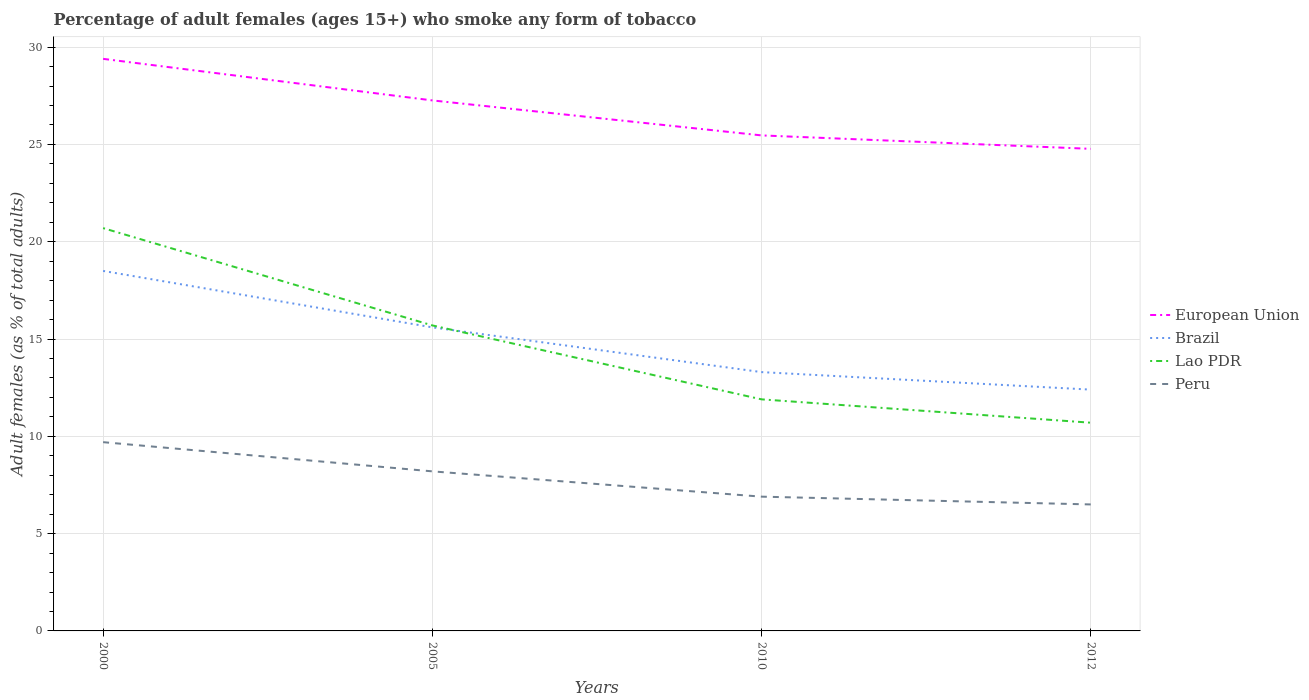Is the number of lines equal to the number of legend labels?
Give a very brief answer. Yes. Across all years, what is the maximum percentage of adult females who smoke in Peru?
Make the answer very short. 6.5. In which year was the percentage of adult females who smoke in European Union maximum?
Keep it short and to the point. 2012. What is the total percentage of adult females who smoke in Peru in the graph?
Offer a terse response. 3.2. What is the difference between the highest and the second highest percentage of adult females who smoke in European Union?
Give a very brief answer. 4.62. What is the difference between the highest and the lowest percentage of adult females who smoke in Lao PDR?
Keep it short and to the point. 2. How many lines are there?
Your answer should be very brief. 4. Are the values on the major ticks of Y-axis written in scientific E-notation?
Offer a very short reply. No. Does the graph contain any zero values?
Your answer should be very brief. No. Does the graph contain grids?
Make the answer very short. Yes. How many legend labels are there?
Make the answer very short. 4. How are the legend labels stacked?
Make the answer very short. Vertical. What is the title of the graph?
Offer a terse response. Percentage of adult females (ages 15+) who smoke any form of tobacco. What is the label or title of the Y-axis?
Offer a terse response. Adult females (as % of total adults). What is the Adult females (as % of total adults) of European Union in 2000?
Offer a very short reply. 29.4. What is the Adult females (as % of total adults) of Brazil in 2000?
Your answer should be very brief. 18.5. What is the Adult females (as % of total adults) of Lao PDR in 2000?
Give a very brief answer. 20.7. What is the Adult females (as % of total adults) in European Union in 2005?
Your response must be concise. 27.26. What is the Adult females (as % of total adults) of Brazil in 2005?
Your answer should be very brief. 15.6. What is the Adult females (as % of total adults) in Lao PDR in 2005?
Provide a short and direct response. 15.7. What is the Adult females (as % of total adults) in Peru in 2005?
Your answer should be very brief. 8.2. What is the Adult females (as % of total adults) in European Union in 2010?
Your response must be concise. 25.46. What is the Adult females (as % of total adults) in Brazil in 2010?
Provide a succinct answer. 13.3. What is the Adult females (as % of total adults) of Lao PDR in 2010?
Your answer should be very brief. 11.9. What is the Adult females (as % of total adults) in European Union in 2012?
Give a very brief answer. 24.77. What is the Adult females (as % of total adults) of Brazil in 2012?
Keep it short and to the point. 12.4. What is the Adult females (as % of total adults) in Lao PDR in 2012?
Your answer should be compact. 10.7. What is the Adult females (as % of total adults) of Peru in 2012?
Offer a terse response. 6.5. Across all years, what is the maximum Adult females (as % of total adults) of European Union?
Offer a terse response. 29.4. Across all years, what is the maximum Adult females (as % of total adults) in Lao PDR?
Give a very brief answer. 20.7. Across all years, what is the minimum Adult females (as % of total adults) of European Union?
Give a very brief answer. 24.77. Across all years, what is the minimum Adult females (as % of total adults) in Lao PDR?
Ensure brevity in your answer.  10.7. Across all years, what is the minimum Adult females (as % of total adults) of Peru?
Give a very brief answer. 6.5. What is the total Adult females (as % of total adults) of European Union in the graph?
Your answer should be very brief. 106.9. What is the total Adult females (as % of total adults) in Brazil in the graph?
Give a very brief answer. 59.8. What is the total Adult females (as % of total adults) in Peru in the graph?
Offer a very short reply. 31.3. What is the difference between the Adult females (as % of total adults) in European Union in 2000 and that in 2005?
Offer a terse response. 2.14. What is the difference between the Adult females (as % of total adults) in Lao PDR in 2000 and that in 2005?
Provide a short and direct response. 5. What is the difference between the Adult females (as % of total adults) of Peru in 2000 and that in 2005?
Keep it short and to the point. 1.5. What is the difference between the Adult females (as % of total adults) in European Union in 2000 and that in 2010?
Provide a short and direct response. 3.93. What is the difference between the Adult females (as % of total adults) of Brazil in 2000 and that in 2010?
Your answer should be compact. 5.2. What is the difference between the Adult females (as % of total adults) of Lao PDR in 2000 and that in 2010?
Provide a short and direct response. 8.8. What is the difference between the Adult females (as % of total adults) of Peru in 2000 and that in 2010?
Provide a short and direct response. 2.8. What is the difference between the Adult females (as % of total adults) in European Union in 2000 and that in 2012?
Provide a short and direct response. 4.62. What is the difference between the Adult females (as % of total adults) of Brazil in 2000 and that in 2012?
Give a very brief answer. 6.1. What is the difference between the Adult females (as % of total adults) of Lao PDR in 2000 and that in 2012?
Offer a terse response. 10. What is the difference between the Adult females (as % of total adults) in Peru in 2000 and that in 2012?
Provide a succinct answer. 3.2. What is the difference between the Adult females (as % of total adults) in European Union in 2005 and that in 2010?
Make the answer very short. 1.8. What is the difference between the Adult females (as % of total adults) in Lao PDR in 2005 and that in 2010?
Offer a very short reply. 3.8. What is the difference between the Adult females (as % of total adults) in European Union in 2005 and that in 2012?
Offer a terse response. 2.49. What is the difference between the Adult females (as % of total adults) of Lao PDR in 2005 and that in 2012?
Give a very brief answer. 5. What is the difference between the Adult females (as % of total adults) in European Union in 2010 and that in 2012?
Your answer should be very brief. 0.69. What is the difference between the Adult females (as % of total adults) in Brazil in 2010 and that in 2012?
Keep it short and to the point. 0.9. What is the difference between the Adult females (as % of total adults) in Lao PDR in 2010 and that in 2012?
Your answer should be compact. 1.2. What is the difference between the Adult females (as % of total adults) of European Union in 2000 and the Adult females (as % of total adults) of Brazil in 2005?
Your answer should be compact. 13.8. What is the difference between the Adult females (as % of total adults) in European Union in 2000 and the Adult females (as % of total adults) in Lao PDR in 2005?
Offer a very short reply. 13.7. What is the difference between the Adult females (as % of total adults) of European Union in 2000 and the Adult females (as % of total adults) of Peru in 2005?
Your response must be concise. 21.2. What is the difference between the Adult females (as % of total adults) of European Union in 2000 and the Adult females (as % of total adults) of Brazil in 2010?
Give a very brief answer. 16.1. What is the difference between the Adult females (as % of total adults) in European Union in 2000 and the Adult females (as % of total adults) in Lao PDR in 2010?
Offer a very short reply. 17.5. What is the difference between the Adult females (as % of total adults) in European Union in 2000 and the Adult females (as % of total adults) in Peru in 2010?
Keep it short and to the point. 22.5. What is the difference between the Adult females (as % of total adults) in Brazil in 2000 and the Adult females (as % of total adults) in Lao PDR in 2010?
Provide a short and direct response. 6.6. What is the difference between the Adult females (as % of total adults) in European Union in 2000 and the Adult females (as % of total adults) in Brazil in 2012?
Offer a terse response. 17. What is the difference between the Adult females (as % of total adults) of European Union in 2000 and the Adult females (as % of total adults) of Lao PDR in 2012?
Your response must be concise. 18.7. What is the difference between the Adult females (as % of total adults) of European Union in 2000 and the Adult females (as % of total adults) of Peru in 2012?
Provide a succinct answer. 22.9. What is the difference between the Adult females (as % of total adults) in Brazil in 2000 and the Adult females (as % of total adults) in Lao PDR in 2012?
Offer a terse response. 7.8. What is the difference between the Adult females (as % of total adults) of European Union in 2005 and the Adult females (as % of total adults) of Brazil in 2010?
Your response must be concise. 13.96. What is the difference between the Adult females (as % of total adults) of European Union in 2005 and the Adult females (as % of total adults) of Lao PDR in 2010?
Ensure brevity in your answer.  15.36. What is the difference between the Adult females (as % of total adults) of European Union in 2005 and the Adult females (as % of total adults) of Peru in 2010?
Keep it short and to the point. 20.36. What is the difference between the Adult females (as % of total adults) in Brazil in 2005 and the Adult females (as % of total adults) in Lao PDR in 2010?
Give a very brief answer. 3.7. What is the difference between the Adult females (as % of total adults) in European Union in 2005 and the Adult females (as % of total adults) in Brazil in 2012?
Offer a very short reply. 14.86. What is the difference between the Adult females (as % of total adults) of European Union in 2005 and the Adult females (as % of total adults) of Lao PDR in 2012?
Make the answer very short. 16.56. What is the difference between the Adult females (as % of total adults) in European Union in 2005 and the Adult females (as % of total adults) in Peru in 2012?
Offer a terse response. 20.76. What is the difference between the Adult females (as % of total adults) in Lao PDR in 2005 and the Adult females (as % of total adults) in Peru in 2012?
Ensure brevity in your answer.  9.2. What is the difference between the Adult females (as % of total adults) in European Union in 2010 and the Adult females (as % of total adults) in Brazil in 2012?
Provide a short and direct response. 13.06. What is the difference between the Adult females (as % of total adults) in European Union in 2010 and the Adult females (as % of total adults) in Lao PDR in 2012?
Make the answer very short. 14.76. What is the difference between the Adult females (as % of total adults) in European Union in 2010 and the Adult females (as % of total adults) in Peru in 2012?
Offer a terse response. 18.96. What is the difference between the Adult females (as % of total adults) in Brazil in 2010 and the Adult females (as % of total adults) in Lao PDR in 2012?
Offer a very short reply. 2.6. What is the difference between the Adult females (as % of total adults) in Lao PDR in 2010 and the Adult females (as % of total adults) in Peru in 2012?
Your answer should be compact. 5.4. What is the average Adult females (as % of total adults) of European Union per year?
Make the answer very short. 26.72. What is the average Adult females (as % of total adults) in Brazil per year?
Your response must be concise. 14.95. What is the average Adult females (as % of total adults) of Lao PDR per year?
Give a very brief answer. 14.75. What is the average Adult females (as % of total adults) of Peru per year?
Your response must be concise. 7.83. In the year 2000, what is the difference between the Adult females (as % of total adults) of European Union and Adult females (as % of total adults) of Brazil?
Your response must be concise. 10.9. In the year 2000, what is the difference between the Adult females (as % of total adults) of European Union and Adult females (as % of total adults) of Lao PDR?
Your answer should be very brief. 8.7. In the year 2000, what is the difference between the Adult females (as % of total adults) in European Union and Adult females (as % of total adults) in Peru?
Keep it short and to the point. 19.7. In the year 2000, what is the difference between the Adult females (as % of total adults) of Brazil and Adult females (as % of total adults) of Lao PDR?
Your answer should be very brief. -2.2. In the year 2005, what is the difference between the Adult females (as % of total adults) in European Union and Adult females (as % of total adults) in Brazil?
Provide a succinct answer. 11.66. In the year 2005, what is the difference between the Adult females (as % of total adults) of European Union and Adult females (as % of total adults) of Lao PDR?
Ensure brevity in your answer.  11.56. In the year 2005, what is the difference between the Adult females (as % of total adults) of European Union and Adult females (as % of total adults) of Peru?
Make the answer very short. 19.06. In the year 2005, what is the difference between the Adult females (as % of total adults) in Brazil and Adult females (as % of total adults) in Peru?
Give a very brief answer. 7.4. In the year 2010, what is the difference between the Adult females (as % of total adults) of European Union and Adult females (as % of total adults) of Brazil?
Keep it short and to the point. 12.16. In the year 2010, what is the difference between the Adult females (as % of total adults) of European Union and Adult females (as % of total adults) of Lao PDR?
Your response must be concise. 13.56. In the year 2010, what is the difference between the Adult females (as % of total adults) in European Union and Adult females (as % of total adults) in Peru?
Your answer should be very brief. 18.56. In the year 2010, what is the difference between the Adult females (as % of total adults) of Brazil and Adult females (as % of total adults) of Lao PDR?
Provide a short and direct response. 1.4. In the year 2012, what is the difference between the Adult females (as % of total adults) of European Union and Adult females (as % of total adults) of Brazil?
Your answer should be compact. 12.37. In the year 2012, what is the difference between the Adult females (as % of total adults) of European Union and Adult females (as % of total adults) of Lao PDR?
Give a very brief answer. 14.07. In the year 2012, what is the difference between the Adult females (as % of total adults) in European Union and Adult females (as % of total adults) in Peru?
Ensure brevity in your answer.  18.27. In the year 2012, what is the difference between the Adult females (as % of total adults) in Brazil and Adult females (as % of total adults) in Lao PDR?
Keep it short and to the point. 1.7. In the year 2012, what is the difference between the Adult females (as % of total adults) in Brazil and Adult females (as % of total adults) in Peru?
Your answer should be compact. 5.9. What is the ratio of the Adult females (as % of total adults) of European Union in 2000 to that in 2005?
Offer a terse response. 1.08. What is the ratio of the Adult females (as % of total adults) in Brazil in 2000 to that in 2005?
Make the answer very short. 1.19. What is the ratio of the Adult females (as % of total adults) of Lao PDR in 2000 to that in 2005?
Your answer should be compact. 1.32. What is the ratio of the Adult females (as % of total adults) in Peru in 2000 to that in 2005?
Give a very brief answer. 1.18. What is the ratio of the Adult females (as % of total adults) of European Union in 2000 to that in 2010?
Offer a very short reply. 1.15. What is the ratio of the Adult females (as % of total adults) of Brazil in 2000 to that in 2010?
Provide a succinct answer. 1.39. What is the ratio of the Adult females (as % of total adults) of Lao PDR in 2000 to that in 2010?
Your answer should be very brief. 1.74. What is the ratio of the Adult females (as % of total adults) of Peru in 2000 to that in 2010?
Your response must be concise. 1.41. What is the ratio of the Adult females (as % of total adults) of European Union in 2000 to that in 2012?
Provide a succinct answer. 1.19. What is the ratio of the Adult females (as % of total adults) of Brazil in 2000 to that in 2012?
Your response must be concise. 1.49. What is the ratio of the Adult females (as % of total adults) in Lao PDR in 2000 to that in 2012?
Your response must be concise. 1.93. What is the ratio of the Adult females (as % of total adults) of Peru in 2000 to that in 2012?
Your answer should be very brief. 1.49. What is the ratio of the Adult females (as % of total adults) in European Union in 2005 to that in 2010?
Ensure brevity in your answer.  1.07. What is the ratio of the Adult females (as % of total adults) in Brazil in 2005 to that in 2010?
Offer a very short reply. 1.17. What is the ratio of the Adult females (as % of total adults) of Lao PDR in 2005 to that in 2010?
Offer a very short reply. 1.32. What is the ratio of the Adult females (as % of total adults) of Peru in 2005 to that in 2010?
Offer a terse response. 1.19. What is the ratio of the Adult females (as % of total adults) in European Union in 2005 to that in 2012?
Give a very brief answer. 1.1. What is the ratio of the Adult females (as % of total adults) in Brazil in 2005 to that in 2012?
Your answer should be very brief. 1.26. What is the ratio of the Adult females (as % of total adults) of Lao PDR in 2005 to that in 2012?
Give a very brief answer. 1.47. What is the ratio of the Adult females (as % of total adults) of Peru in 2005 to that in 2012?
Your response must be concise. 1.26. What is the ratio of the Adult females (as % of total adults) of European Union in 2010 to that in 2012?
Give a very brief answer. 1.03. What is the ratio of the Adult females (as % of total adults) of Brazil in 2010 to that in 2012?
Provide a succinct answer. 1.07. What is the ratio of the Adult females (as % of total adults) of Lao PDR in 2010 to that in 2012?
Your response must be concise. 1.11. What is the ratio of the Adult females (as % of total adults) in Peru in 2010 to that in 2012?
Offer a very short reply. 1.06. What is the difference between the highest and the second highest Adult females (as % of total adults) of European Union?
Ensure brevity in your answer.  2.14. What is the difference between the highest and the second highest Adult females (as % of total adults) of Brazil?
Provide a short and direct response. 2.9. What is the difference between the highest and the second highest Adult females (as % of total adults) of Lao PDR?
Offer a very short reply. 5. What is the difference between the highest and the lowest Adult females (as % of total adults) in European Union?
Offer a terse response. 4.62. What is the difference between the highest and the lowest Adult females (as % of total adults) of Brazil?
Your answer should be very brief. 6.1. What is the difference between the highest and the lowest Adult females (as % of total adults) in Lao PDR?
Ensure brevity in your answer.  10. 